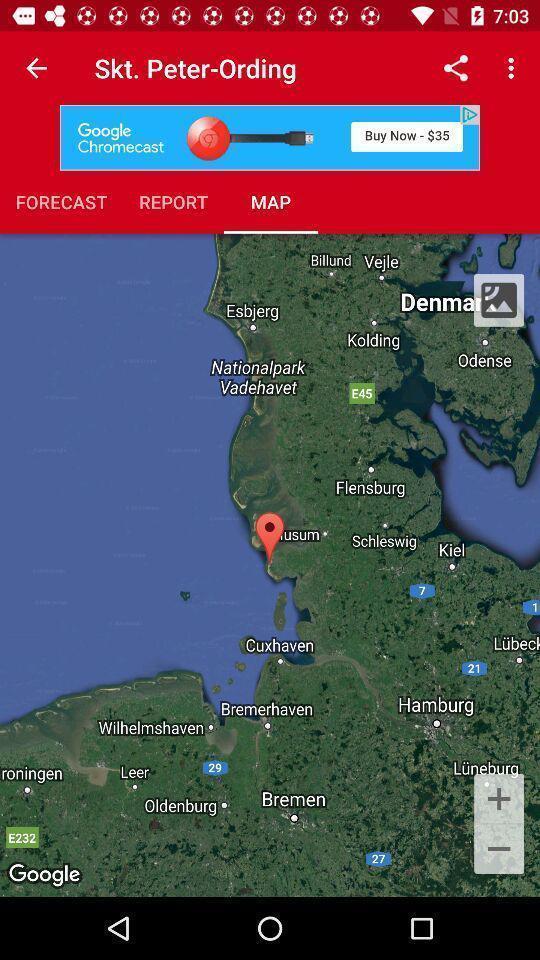Give me a summary of this screen capture. Page displays multiple options of mapping app. 